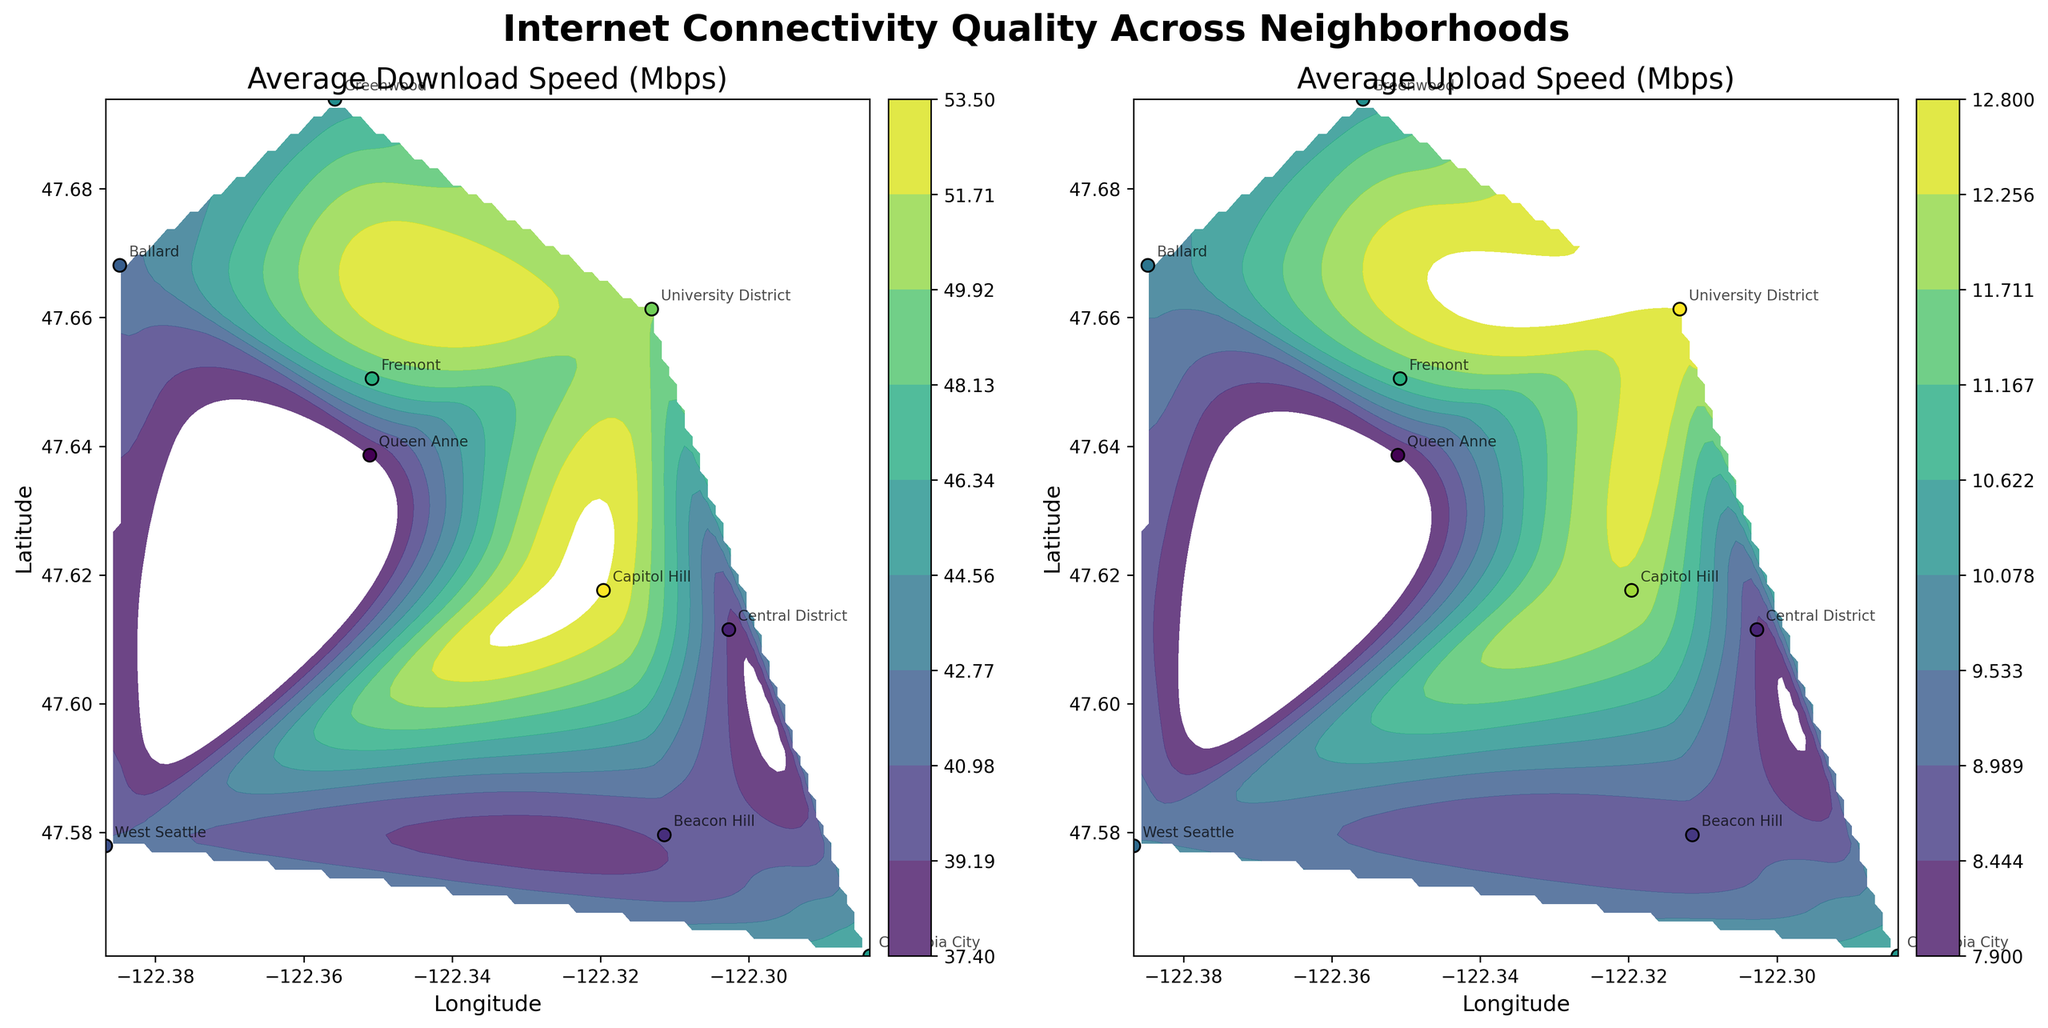What's the overall theme of the figure? The title of the figure says "Internet Connectivity Quality Across Neighborhoods," and the figure includes two subplots, each showing internet quality metrics across different neighborhoods in a city.
Answer: Internet Connectivity Quality Across Neighborhoods What is the title of the first subplot? The title of the first subplot is displayed above it.
Answer: Average Download Speed (Mbps) What does the color bar in the first subplot represent? The color bar in the first subplot shows the range of average download speeds in Mbps.
Answer: Average download speeds Which neighborhood has the highest average download speed? Honolulu has the highest contour level in the first subplot, showing the highest average download speed.
Answer: Capitol Hill What range of latitudes are covered in the figure? The latitude axis of both subplots represents the range of latitudes.
Answer: Approximately 47.56 - 47.69 How many neighborhoods are represented in this figure? Each marked data point represents a neighborhood, and counting these points reveals the total number.
Answer: 10 What is the download speed difference between Capitol Hill and Greenwood? From the labels in the first subplot, Capitol Hill has 53.5 Mbps and Greenwood has 45.2 Mbps. The difference is calculated as 53.5 - 45.2.
Answer: 8.3 Mbps Which subplots have a greater visual spread in quality, download speed or upload speed? By comparing the contour distributions in both subplots, we can see the extent of variations in these metrics.
Answer: Download speed Is there a neighborhood that appears in a high-speed region for both download and upload speeds? Identifying neighborhoods that fall within high contour levels in both subplots reveals which neighborhoods have high speeds for both metrics.
Answer: University District Estimate the latitude and longitude where the highest upload speeds are found. Highest upload speeds are found at the peak contour levels in the second subplot, and their location can be estimated by eyeing the axis values.
Answer: Approximately 47.6176, -122.3196 